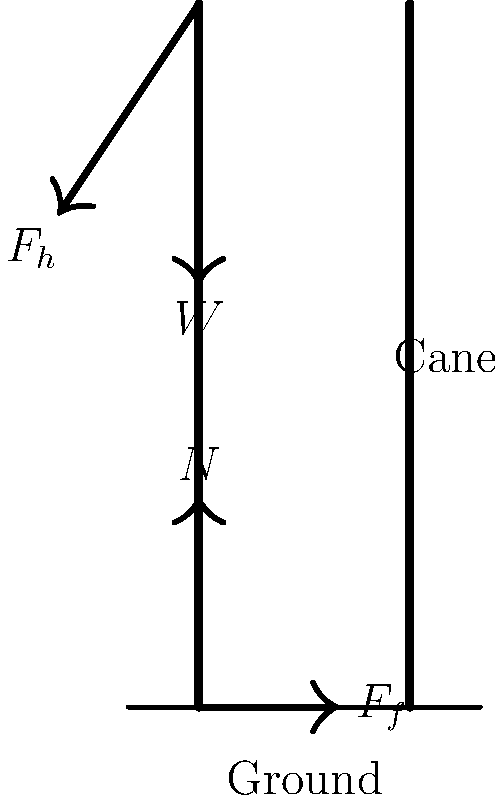In the force diagram of a senior using a walking cane, which force counteracts the horizontal component of the force applied by the hand ($F_h$) to maintain static equilibrium? To understand this problem, let's break it down step-by-step:

1) The forces acting on the cane are:
   - $F_h$: Force applied by the hand
   - $W$: Weight of the cane
   - $N$: Normal force from the ground
   - $F_f$: Friction force from the ground

2) For static equilibrium, the sum of all forces must be zero in both horizontal and vertical directions.

3) In the vertical direction:
   The upward normal force $N$ balances the downward forces (weight of the cane $W$ and vertical component of $F_h$).

4) In the horizontal direction:
   The force $F_h$ has a horizontal component pushing the cane forward.

5) To maintain equilibrium, there must be a force acting in the opposite direction to this horizontal component.

6) The only horizontal force acting in the opposite direction is the friction force $F_f$.

7) Therefore, the friction force $F_f$ is the force that counteracts the horizontal component of $F_h$ to maintain static equilibrium.
Answer: Friction force ($F_f$) 